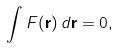Convert formula to latex. <formula><loc_0><loc_0><loc_500><loc_500>\int F ( { \mathbf r } ) \, d { \mathbf r } = 0 ,</formula> 